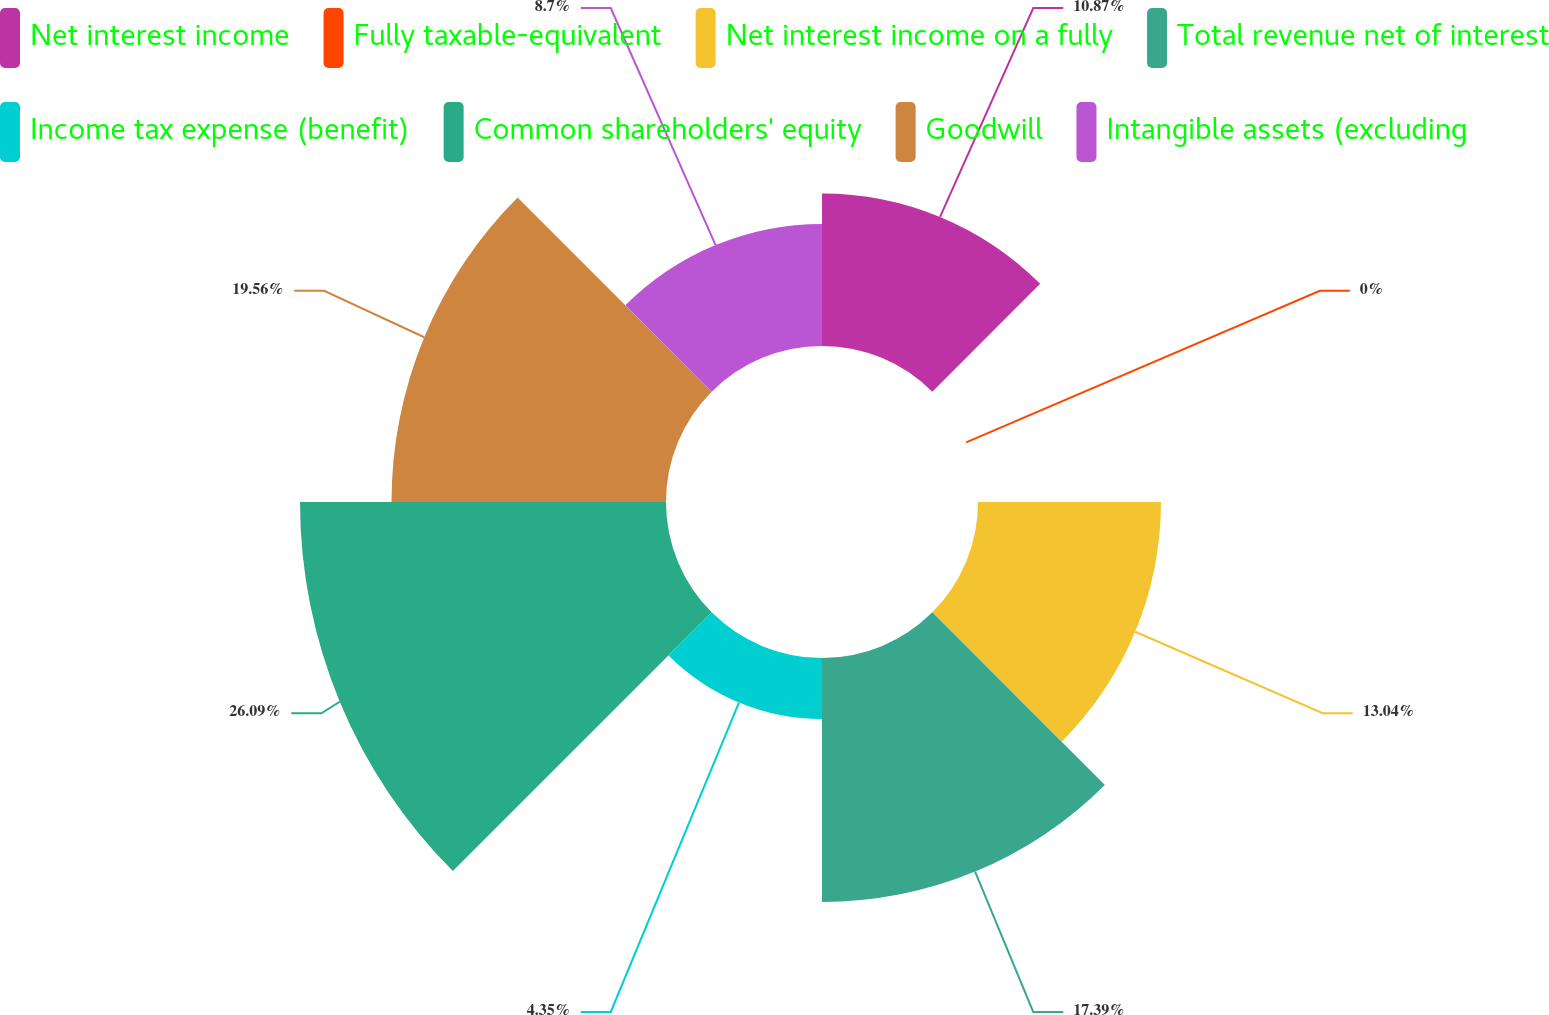Convert chart to OTSL. <chart><loc_0><loc_0><loc_500><loc_500><pie_chart><fcel>Net interest income<fcel>Fully taxable-equivalent<fcel>Net interest income on a fully<fcel>Total revenue net of interest<fcel>Income tax expense (benefit)<fcel>Common shareholders' equity<fcel>Goodwill<fcel>Intangible assets (excluding<nl><fcel>10.87%<fcel>0.0%<fcel>13.04%<fcel>17.39%<fcel>4.35%<fcel>26.08%<fcel>19.56%<fcel>8.7%<nl></chart> 